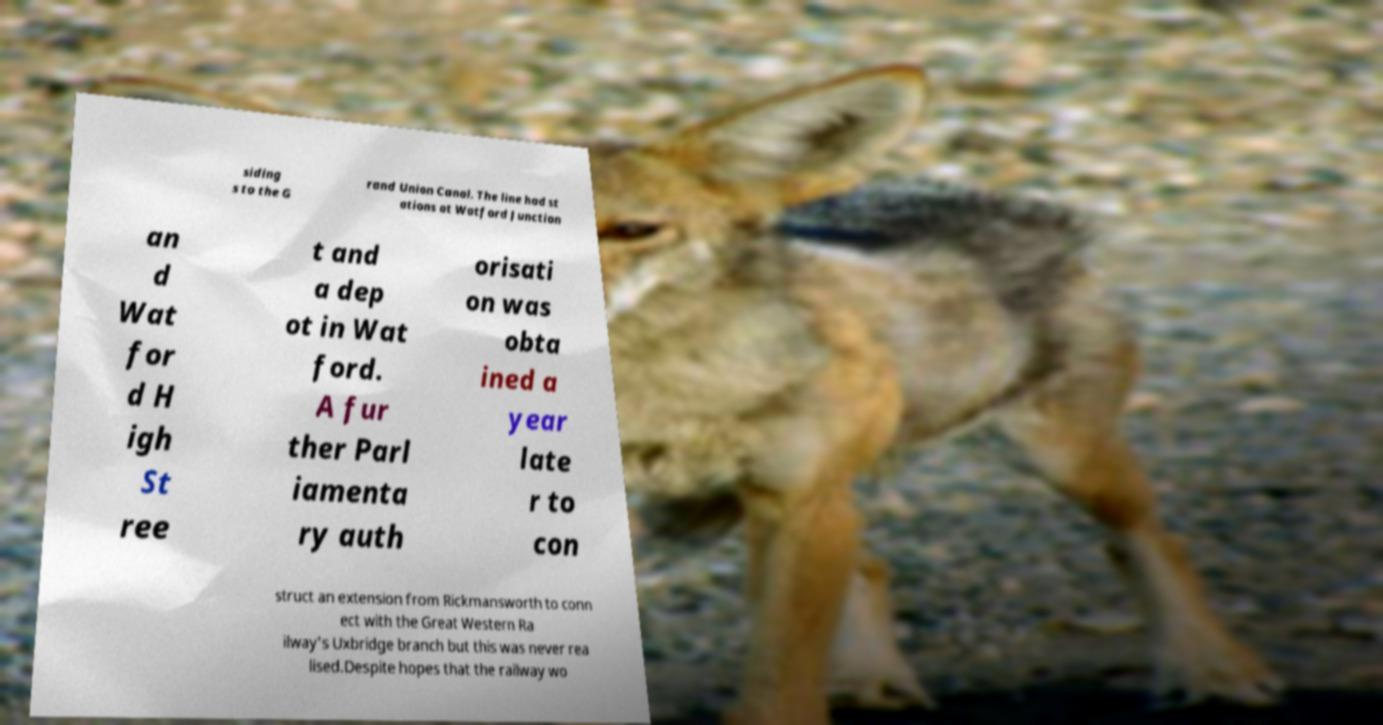Please read and relay the text visible in this image. What does it say? siding s to the G rand Union Canal. The line had st ations at Watford Junction an d Wat for d H igh St ree t and a dep ot in Wat ford. A fur ther Parl iamenta ry auth orisati on was obta ined a year late r to con struct an extension from Rickmansworth to conn ect with the Great Western Ra ilway's Uxbridge branch but this was never rea lised.Despite hopes that the railway wo 